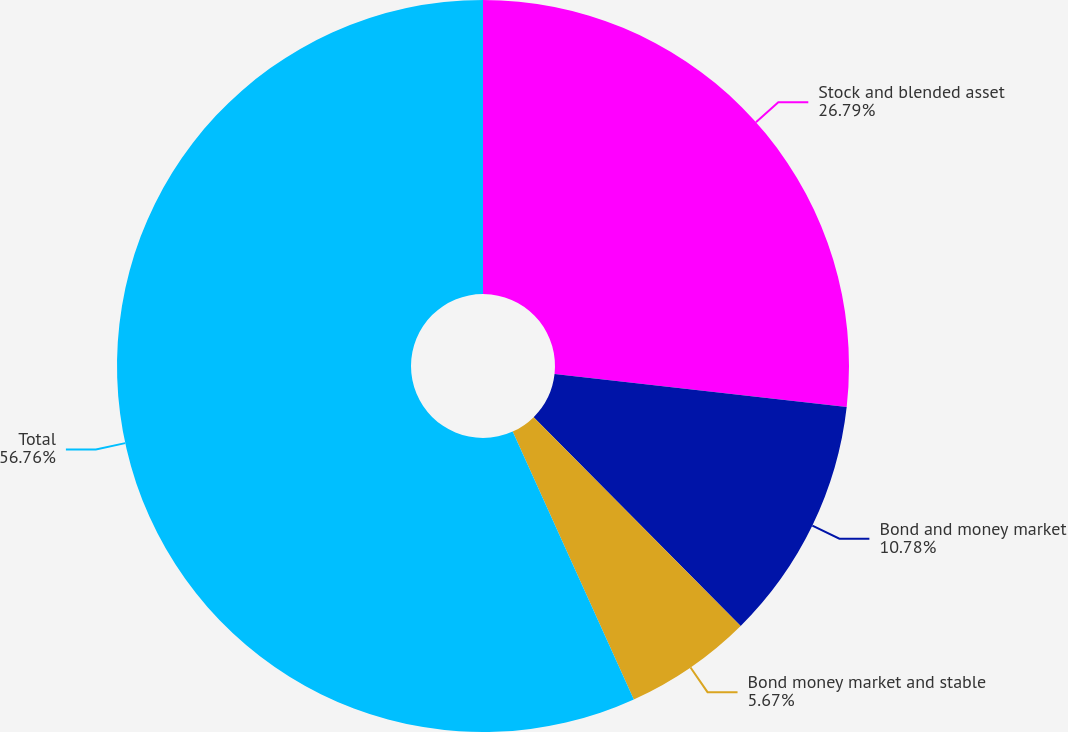Convert chart to OTSL. <chart><loc_0><loc_0><loc_500><loc_500><pie_chart><fcel>Stock and blended asset<fcel>Bond and money market<fcel>Bond money market and stable<fcel>Total<nl><fcel>26.79%<fcel>10.78%<fcel>5.67%<fcel>56.76%<nl></chart> 